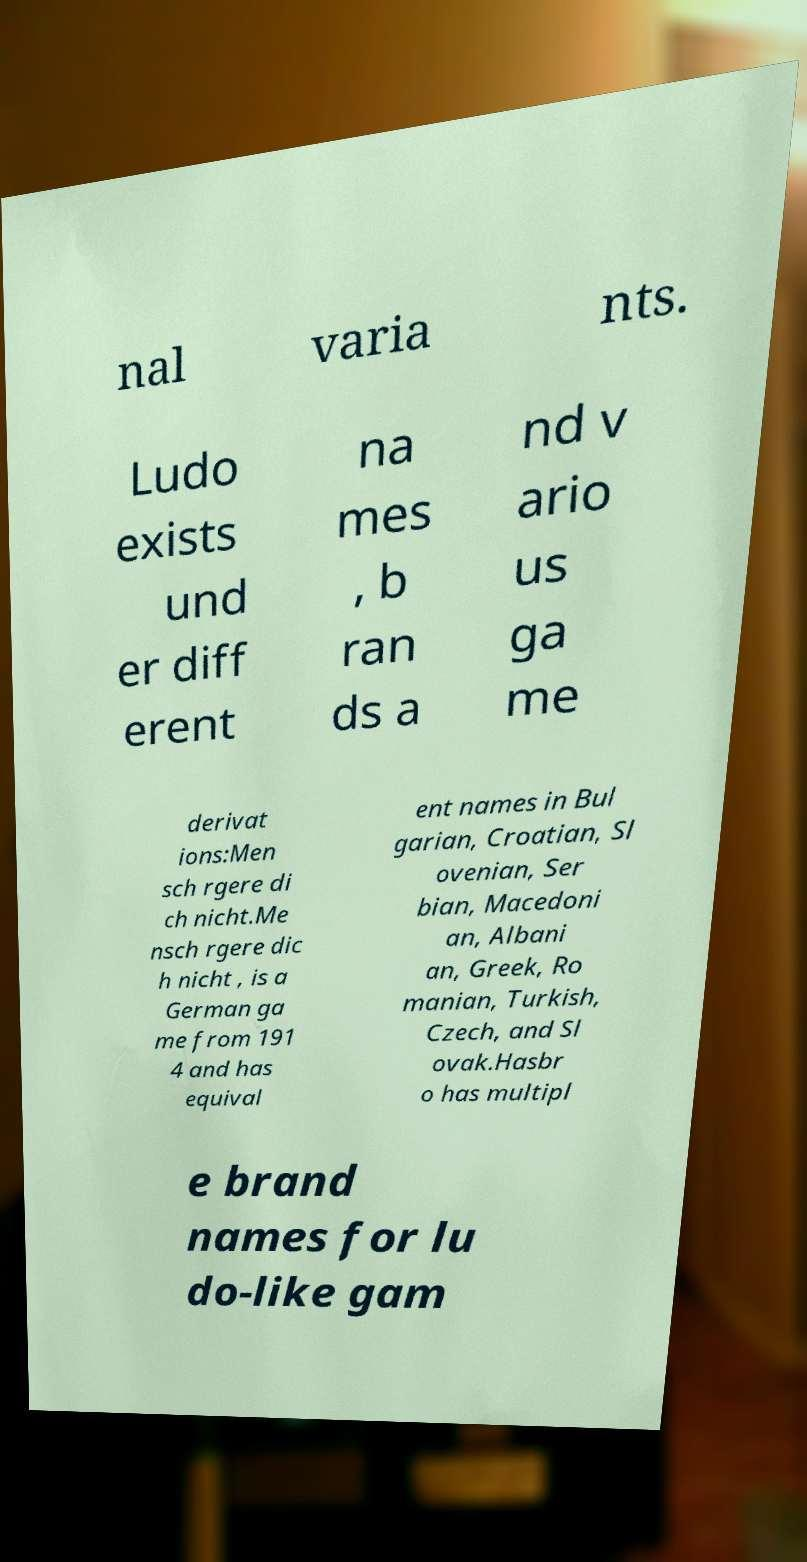Could you assist in decoding the text presented in this image and type it out clearly? nal varia nts. Ludo exists und er diff erent na mes , b ran ds a nd v ario us ga me derivat ions:Men sch rgere di ch nicht.Me nsch rgere dic h nicht , is a German ga me from 191 4 and has equival ent names in Bul garian, Croatian, Sl ovenian, Ser bian, Macedoni an, Albani an, Greek, Ro manian, Turkish, Czech, and Sl ovak.Hasbr o has multipl e brand names for lu do-like gam 